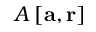Convert formula to latex. <formula><loc_0><loc_0><loc_500><loc_500>A \left [ a , r \right ]</formula> 